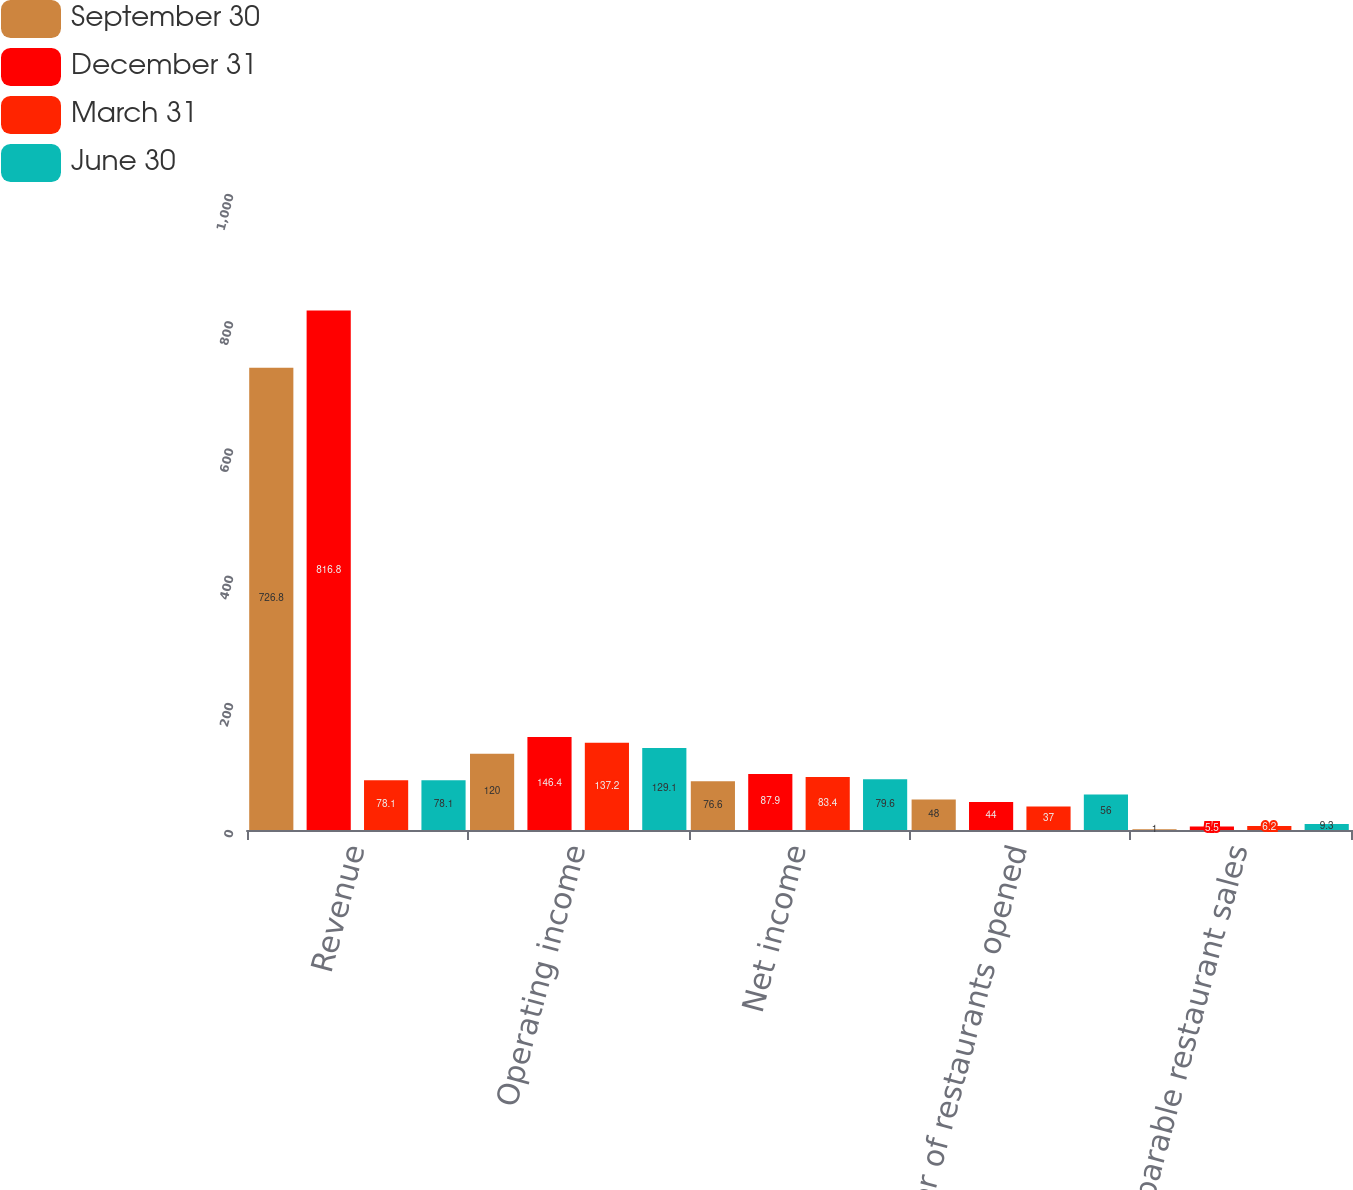Convert chart to OTSL. <chart><loc_0><loc_0><loc_500><loc_500><stacked_bar_chart><ecel><fcel>Revenue<fcel>Operating income<fcel>Net income<fcel>Number of restaurants opened<fcel>Comparable restaurant sales<nl><fcel>September 30<fcel>726.8<fcel>120<fcel>76.6<fcel>48<fcel>1<nl><fcel>December 31<fcel>816.8<fcel>146.4<fcel>87.9<fcel>44<fcel>5.5<nl><fcel>March 31<fcel>78.1<fcel>137.2<fcel>83.4<fcel>37<fcel>6.2<nl><fcel>June 30<fcel>78.1<fcel>129.1<fcel>79.6<fcel>56<fcel>9.3<nl></chart> 